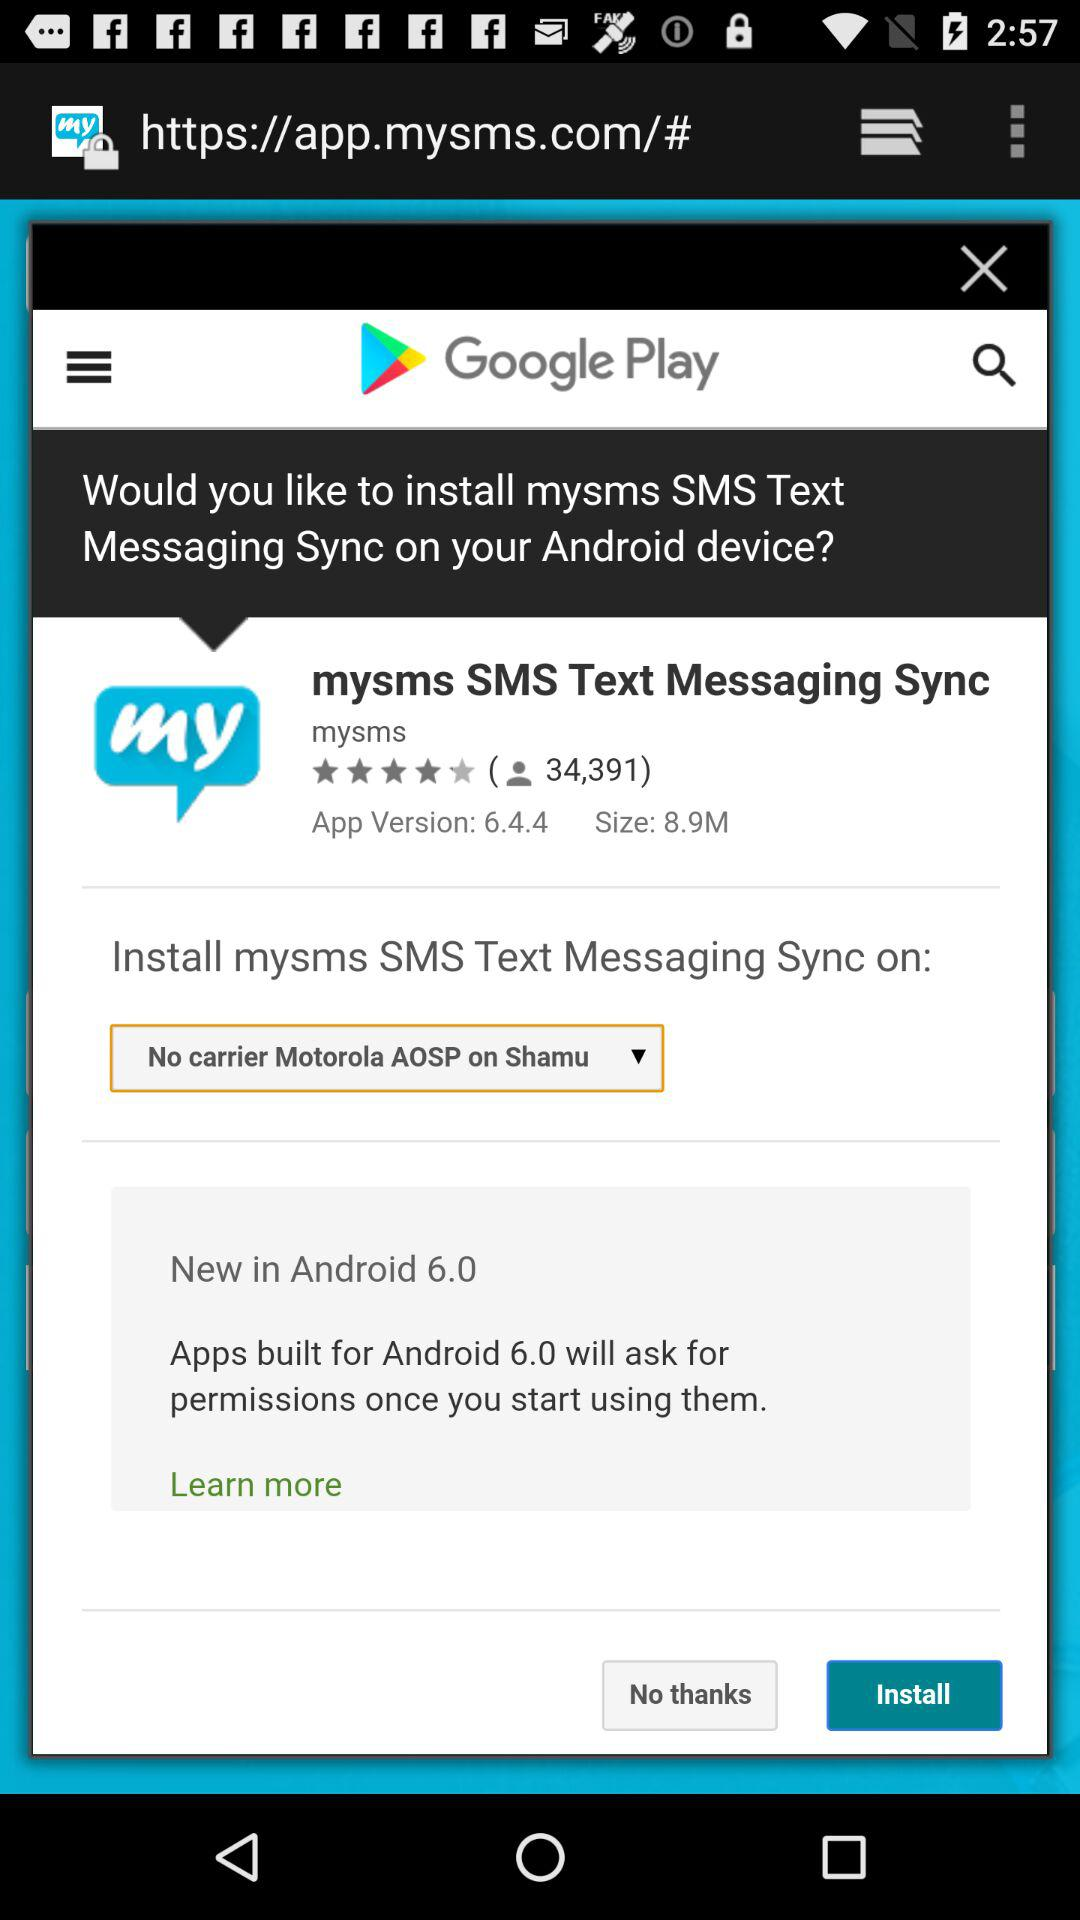What's the app version? The app version is 6.4.4. 